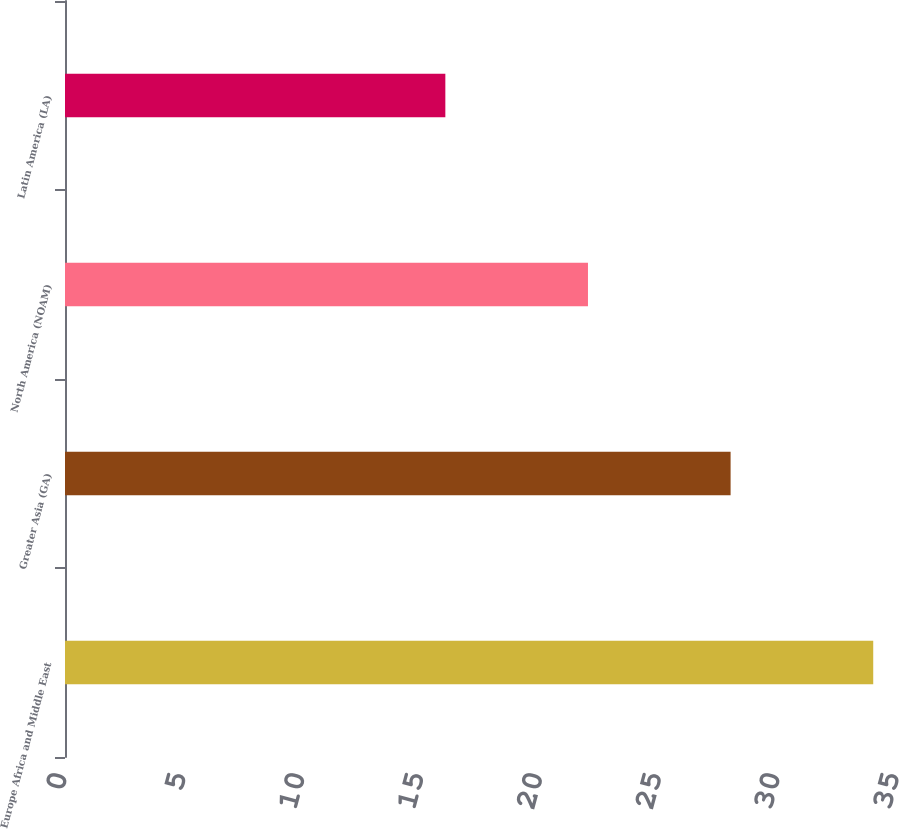Convert chart. <chart><loc_0><loc_0><loc_500><loc_500><bar_chart><fcel>Europe Africa and Middle East<fcel>Greater Asia (GA)<fcel>North America (NOAM)<fcel>Latin America (LA)<nl><fcel>34<fcel>28<fcel>22<fcel>16<nl></chart> 